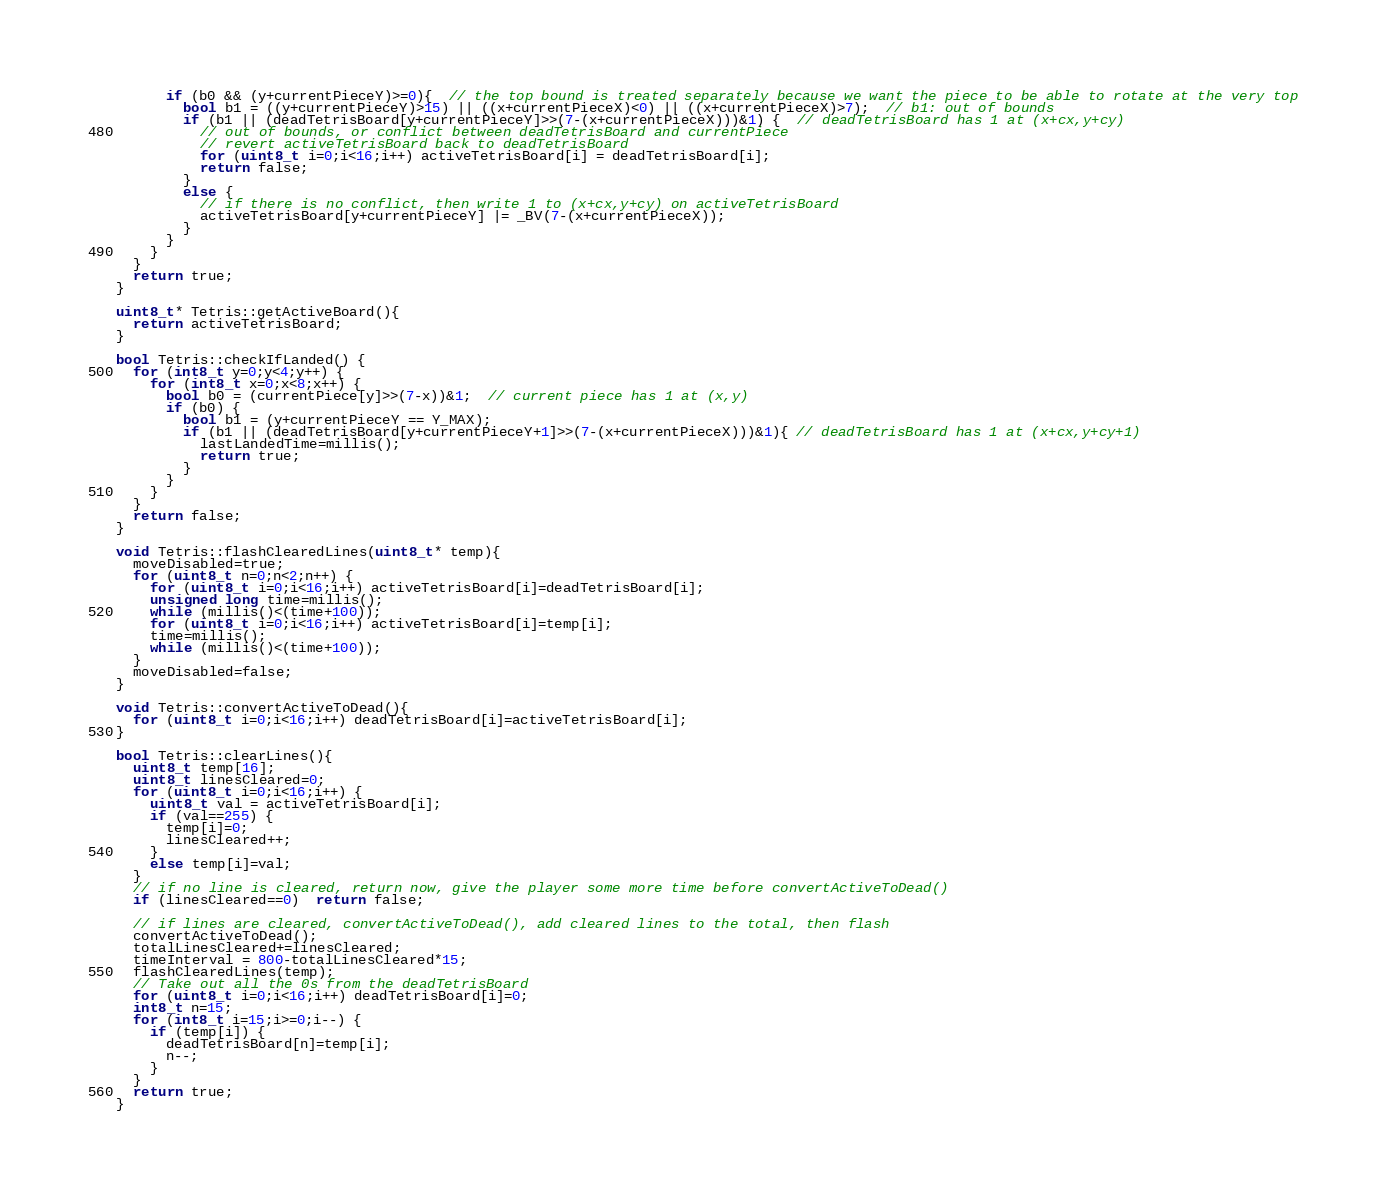<code> <loc_0><loc_0><loc_500><loc_500><_C++_>      if (b0 && (y+currentPieceY)>=0){  // the top bound is treated separately because we want the piece to be able to rotate at the very top
        bool b1 = ((y+currentPieceY)>15) || ((x+currentPieceX)<0) || ((x+currentPieceX)>7);  // b1: out of bounds
        if (b1 || (deadTetrisBoard[y+currentPieceY]>>(7-(x+currentPieceX)))&1) {  // deadTetrisBoard has 1 at (x+cx,y+cy)
          // out of bounds, or conflict between deadTetrisBoard and currentPiece
          // revert activeTetrisBoard back to deadTetrisBoard
          for (uint8_t i=0;i<16;i++) activeTetrisBoard[i] = deadTetrisBoard[i];
          return false;  
        }
        else {
          // if there is no conflict, then write 1 to (x+cx,y+cy) on activeTetrisBoard
          activeTetrisBoard[y+currentPieceY] |= _BV(7-(x+currentPieceX));
        }
      }
    }
  }
  return true;
}

uint8_t* Tetris::getActiveBoard(){
  return activeTetrisBoard;
}

bool Tetris::checkIfLanded() {
  for (int8_t y=0;y<4;y++) {
    for (int8_t x=0;x<8;x++) {
      bool b0 = (currentPiece[y]>>(7-x))&1;  // current piece has 1 at (x,y)
      if (b0) {
        bool b1 = (y+currentPieceY == Y_MAX);
        if (b1 || (deadTetrisBoard[y+currentPieceY+1]>>(7-(x+currentPieceX)))&1){ // deadTetrisBoard has 1 at (x+cx,y+cy+1)
          lastLandedTime=millis();
          return true;
        }
      }
    }
  }
  return false;
}

void Tetris::flashClearedLines(uint8_t* temp){
  moveDisabled=true;
  for (uint8_t n=0;n<2;n++) {
    for (uint8_t i=0;i<16;i++) activeTetrisBoard[i]=deadTetrisBoard[i];
    unsigned long time=millis();
    while (millis()<(time+100));
    for (uint8_t i=0;i<16;i++) activeTetrisBoard[i]=temp[i];
    time=millis();
    while (millis()<(time+100));
  }
  moveDisabled=false;
}

void Tetris::convertActiveToDead(){
  for (uint8_t i=0;i<16;i++) deadTetrisBoard[i]=activeTetrisBoard[i];
}

bool Tetris::clearLines(){
  uint8_t temp[16];
  uint8_t linesCleared=0;
  for (uint8_t i=0;i<16;i++) {
    uint8_t val = activeTetrisBoard[i];
    if (val==255) {
      temp[i]=0;
      linesCleared++;
    }
    else temp[i]=val;
  } 
  // if no line is cleared, return now, give the player some more time before convertActiveToDead()
  if (linesCleared==0)  return false;
  
  // if lines are cleared, convertActiveToDead(), add cleared lines to the total, then flash
  convertActiveToDead();
  totalLinesCleared+=linesCleared;
  timeInterval = 800-totalLinesCleared*15;
  flashClearedLines(temp);
  // Take out all the 0s from the deadTetrisBoard
  for (uint8_t i=0;i<16;i++) deadTetrisBoard[i]=0;
  int8_t n=15;
  for (int8_t i=15;i>=0;i--) {
    if (temp[i]) {
      deadTetrisBoard[n]=temp[i];
      n--;
    }
  }
  return true;
}
</code> 